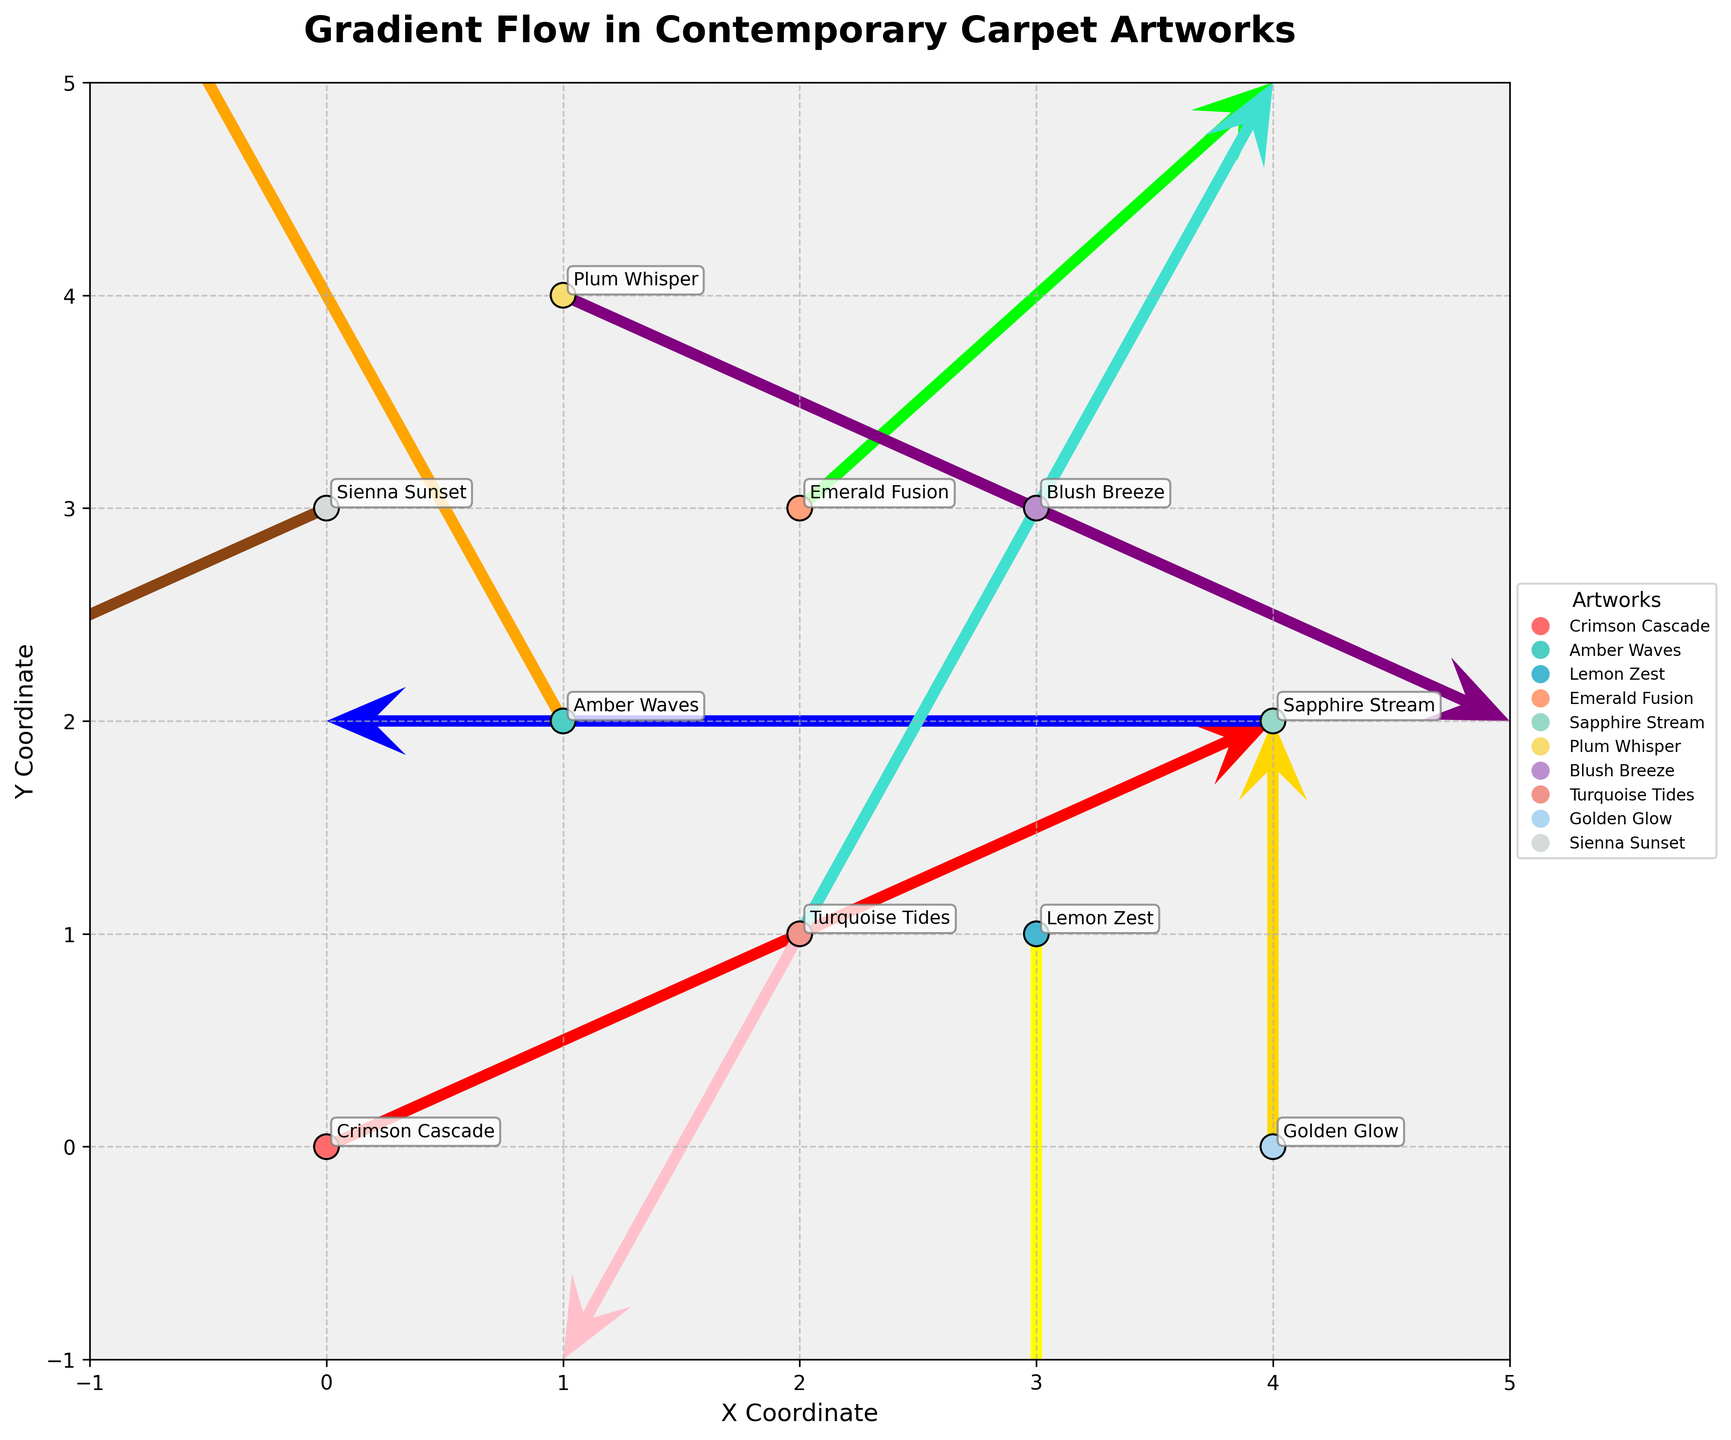What is the title of the plot? The title of the plot can be found at the top of the figure. It is typically centered and in a larger, bold font for emphasis.
Answer: Gradient Flow in Contemporary Carpet Artworks How many data points are represented in the plot? Each data point is marked by both a quiver arrow and an annotated artwork name, which can be counted. There are 10 such points visible in the plot.
Answer: 10 Which artwork name is located at coordinates (4,2)? The coordinates (4,2) can be directly matched with the artwork name in the figure. "Sapphire Stream" is located at those coordinates.
Answer: Sapphire Stream Which color represents the artwork "Emerald Fusion"? The artwork names are annotated next to the quiver arrows, and each is associated with a unique color. "Emerald Fusion" is represented in green.
Answer: Green What is the direction of the quiver arrow for "Blush Breeze"? The direction of the quiver arrows indicates the flow. For "Blush Breeze", the arrow points in the negative x and y directions, meaning it flows towards the bottom-left.
Answer: Bottom-left Which two artworks have their quiver arrows pointing directly upwards? Quiver arrows pointing directly up have a positive y component and zero x component. Both "Turquoise Tides" and "Golden Glow" have arrows pointing upwards.
Answer: Turquoise Tides and Golden Glow Compare the lengths of the arrows for "Crimson Cascade" and "Golden Glow". Which one is longer? Arrow length is determined by the size of the u and v components. "Crimson Cascade" has components (2,1) and "Golden Glow" has (0,1). Using Pythagoras' theorem, the length of "Crimson Cascade" is √(2² + 1²) = √5, and for "Golden Glow" it is 1.
Answer: Crimson Cascade What is the average of the x-coordinates of the artworks located on the right side of the plot (x > 2)? The artworks located on the right side can be seen at coordinates (3,1), (4,2), and (4,0). The average of their x-coordinates is (3 + 4 + 4) / 3 = 3.67.
Answer: 3.67 Which artwork's arrow indicates a horizontal movement only? An arrow indicating only horizontal movement would have no vertical component (v=0). "Sapphire Stream" has components (-2,0), showing it only moves horizontally.
Answer: Sapphire Stream What is the sum of the magnitudes of the vectors for "Amber Waves" and "Blush Breeze"? The magnitude of a vector is found using √(u² + v²). For "Amber Waves" with (-1,2) it is √(1 + 4) = √5, and for "Blush Breeze" with (-1,-2) it is also √5. Thus, the sum is √5 + √5 = 2√5.
Answer: 2√5 